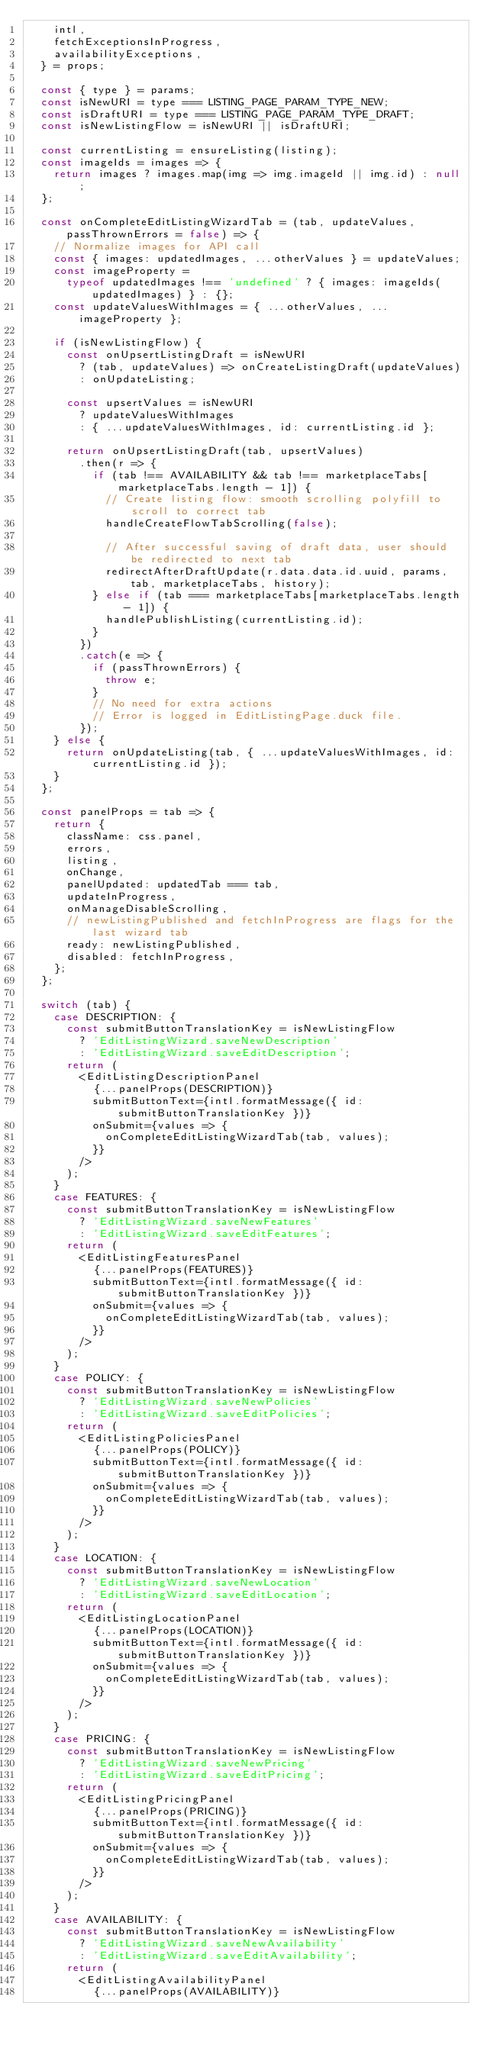Convert code to text. <code><loc_0><loc_0><loc_500><loc_500><_JavaScript_>    intl,
    fetchExceptionsInProgress,
    availabilityExceptions,
  } = props;

  const { type } = params;
  const isNewURI = type === LISTING_PAGE_PARAM_TYPE_NEW;
  const isDraftURI = type === LISTING_PAGE_PARAM_TYPE_DRAFT;
  const isNewListingFlow = isNewURI || isDraftURI;

  const currentListing = ensureListing(listing);
  const imageIds = images => {
    return images ? images.map(img => img.imageId || img.id) : null;
  };

  const onCompleteEditListingWizardTab = (tab, updateValues, passThrownErrors = false) => {
    // Normalize images for API call
    const { images: updatedImages, ...otherValues } = updateValues;
    const imageProperty =
      typeof updatedImages !== 'undefined' ? { images: imageIds(updatedImages) } : {};
    const updateValuesWithImages = { ...otherValues, ...imageProperty };

    if (isNewListingFlow) {
      const onUpsertListingDraft = isNewURI
        ? (tab, updateValues) => onCreateListingDraft(updateValues)
        : onUpdateListing;

      const upsertValues = isNewURI
        ? updateValuesWithImages
        : { ...updateValuesWithImages, id: currentListing.id };

      return onUpsertListingDraft(tab, upsertValues)
        .then(r => {
          if (tab !== AVAILABILITY && tab !== marketplaceTabs[marketplaceTabs.length - 1]) {
            // Create listing flow: smooth scrolling polyfill to scroll to correct tab
            handleCreateFlowTabScrolling(false);

            // After successful saving of draft data, user should be redirected to next tab
            redirectAfterDraftUpdate(r.data.data.id.uuid, params, tab, marketplaceTabs, history);
          } else if (tab === marketplaceTabs[marketplaceTabs.length - 1]) {
            handlePublishListing(currentListing.id);
          }
        })
        .catch(e => {
          if (passThrownErrors) {
            throw e;
          }
          // No need for extra actions
          // Error is logged in EditListingPage.duck file.
        });
    } else {
      return onUpdateListing(tab, { ...updateValuesWithImages, id: currentListing.id });
    }
  };

  const panelProps = tab => {
    return {
      className: css.panel,
      errors,
      listing,
      onChange,
      panelUpdated: updatedTab === tab,
      updateInProgress,
      onManageDisableScrolling,
      // newListingPublished and fetchInProgress are flags for the last wizard tab
      ready: newListingPublished,
      disabled: fetchInProgress,
    };
  };

  switch (tab) {
    case DESCRIPTION: {
      const submitButtonTranslationKey = isNewListingFlow
        ? 'EditListingWizard.saveNewDescription'
        : 'EditListingWizard.saveEditDescription';
      return (
        <EditListingDescriptionPanel
          {...panelProps(DESCRIPTION)}
          submitButtonText={intl.formatMessage({ id: submitButtonTranslationKey })}
          onSubmit={values => {
            onCompleteEditListingWizardTab(tab, values);
          }}
        />
      );
    }
    case FEATURES: {
      const submitButtonTranslationKey = isNewListingFlow
        ? 'EditListingWizard.saveNewFeatures'
        : 'EditListingWizard.saveEditFeatures';
      return (
        <EditListingFeaturesPanel
          {...panelProps(FEATURES)}
          submitButtonText={intl.formatMessage({ id: submitButtonTranslationKey })}
          onSubmit={values => {
            onCompleteEditListingWizardTab(tab, values);
          }}
        />
      );
    }
    case POLICY: {
      const submitButtonTranslationKey = isNewListingFlow
        ? 'EditListingWizard.saveNewPolicies'
        : 'EditListingWizard.saveEditPolicies';
      return (
        <EditListingPoliciesPanel
          {...panelProps(POLICY)}
          submitButtonText={intl.formatMessage({ id: submitButtonTranslationKey })}
          onSubmit={values => {
            onCompleteEditListingWizardTab(tab, values);
          }}
        />
      );
    }
    case LOCATION: {
      const submitButtonTranslationKey = isNewListingFlow
        ? 'EditListingWizard.saveNewLocation'
        : 'EditListingWizard.saveEditLocation';
      return (
        <EditListingLocationPanel
          {...panelProps(LOCATION)}
          submitButtonText={intl.formatMessage({ id: submitButtonTranslationKey })}
          onSubmit={values => {
            onCompleteEditListingWizardTab(tab, values);
          }}
        />
      );
    }
    case PRICING: {
      const submitButtonTranslationKey = isNewListingFlow
        ? 'EditListingWizard.saveNewPricing'
        : 'EditListingWizard.saveEditPricing';
      return (
        <EditListingPricingPanel
          {...panelProps(PRICING)}
          submitButtonText={intl.formatMessage({ id: submitButtonTranslationKey })}
          onSubmit={values => {
            onCompleteEditListingWizardTab(tab, values);
          }}
        />
      );
    }
    case AVAILABILITY: {
      const submitButtonTranslationKey = isNewListingFlow
        ? 'EditListingWizard.saveNewAvailability'
        : 'EditListingWizard.saveEditAvailability';
      return (
        <EditListingAvailabilityPanel
          {...panelProps(AVAILABILITY)}</code> 